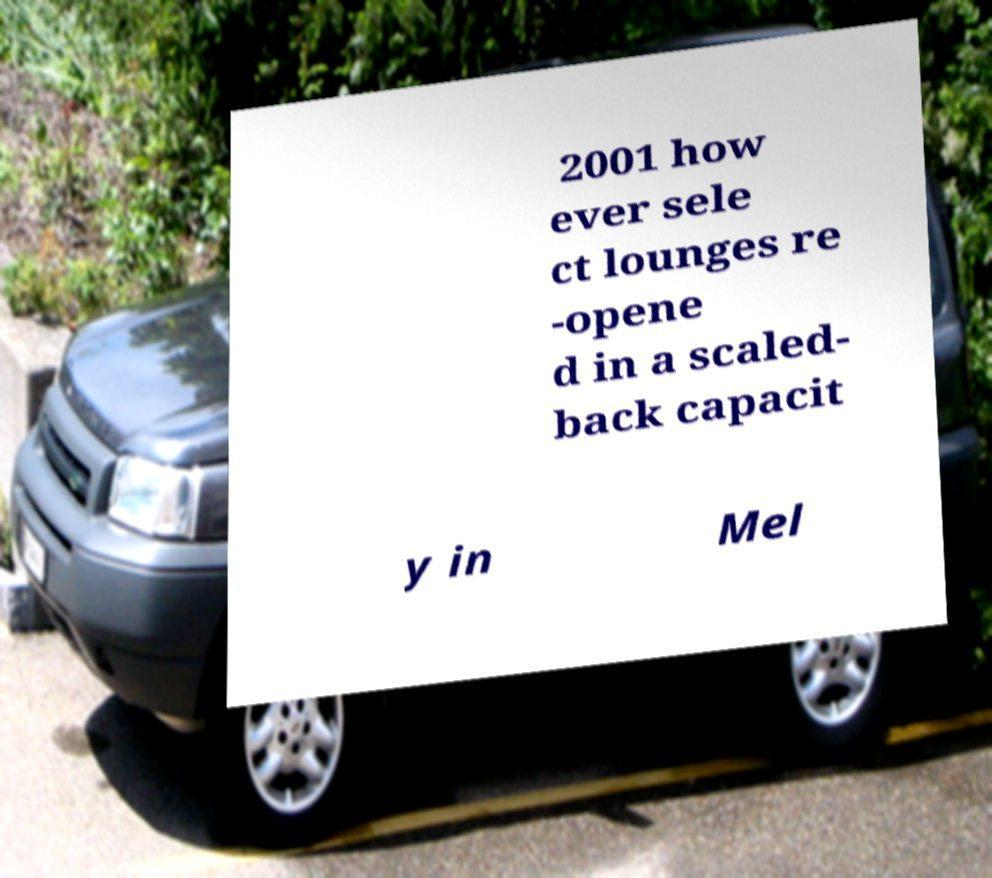Could you extract and type out the text from this image? 2001 how ever sele ct lounges re -opene d in a scaled- back capacit y in Mel 